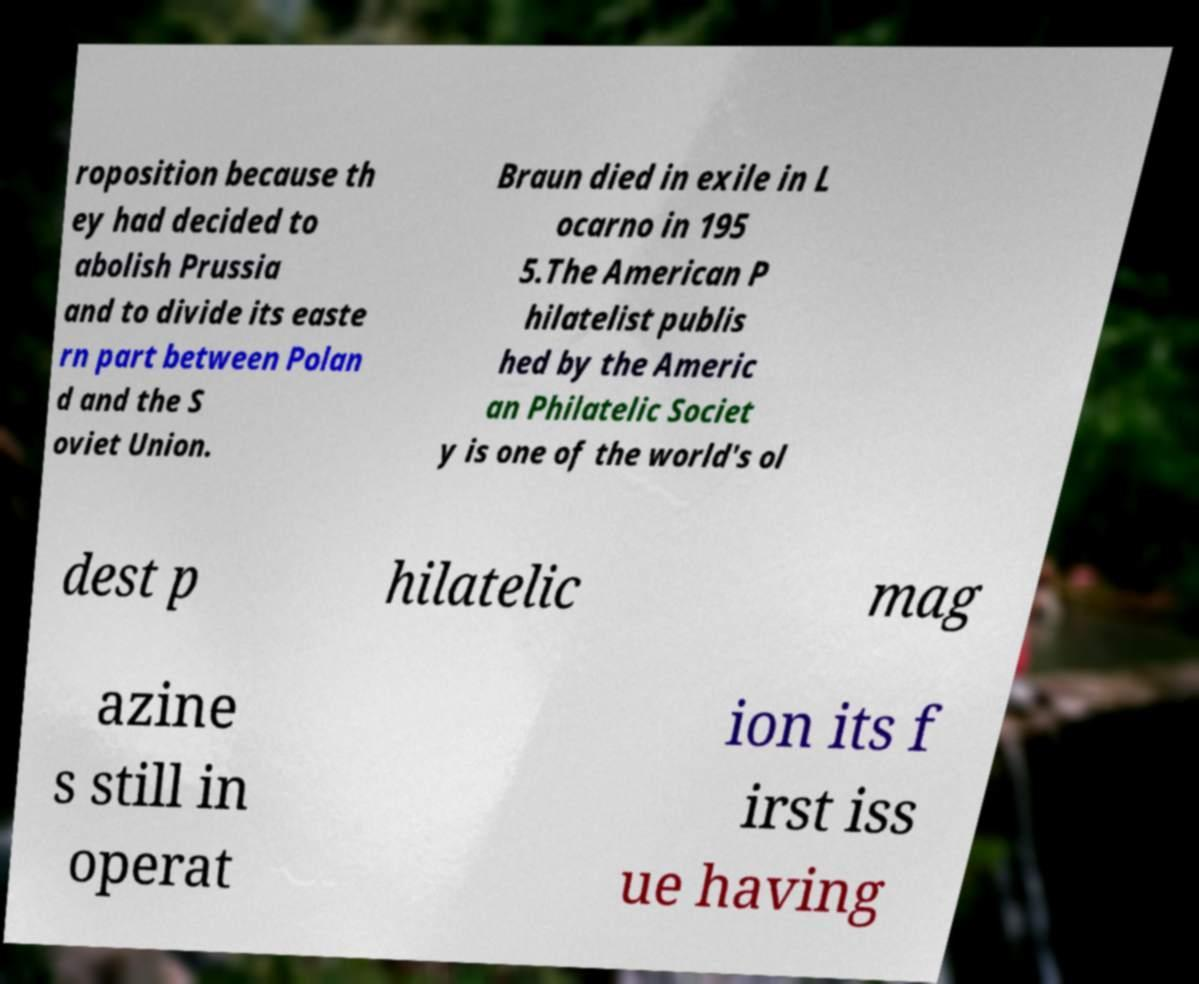Could you assist in decoding the text presented in this image and type it out clearly? roposition because th ey had decided to abolish Prussia and to divide its easte rn part between Polan d and the S oviet Union. Braun died in exile in L ocarno in 195 5.The American P hilatelist publis hed by the Americ an Philatelic Societ y is one of the world's ol dest p hilatelic mag azine s still in operat ion its f irst iss ue having 